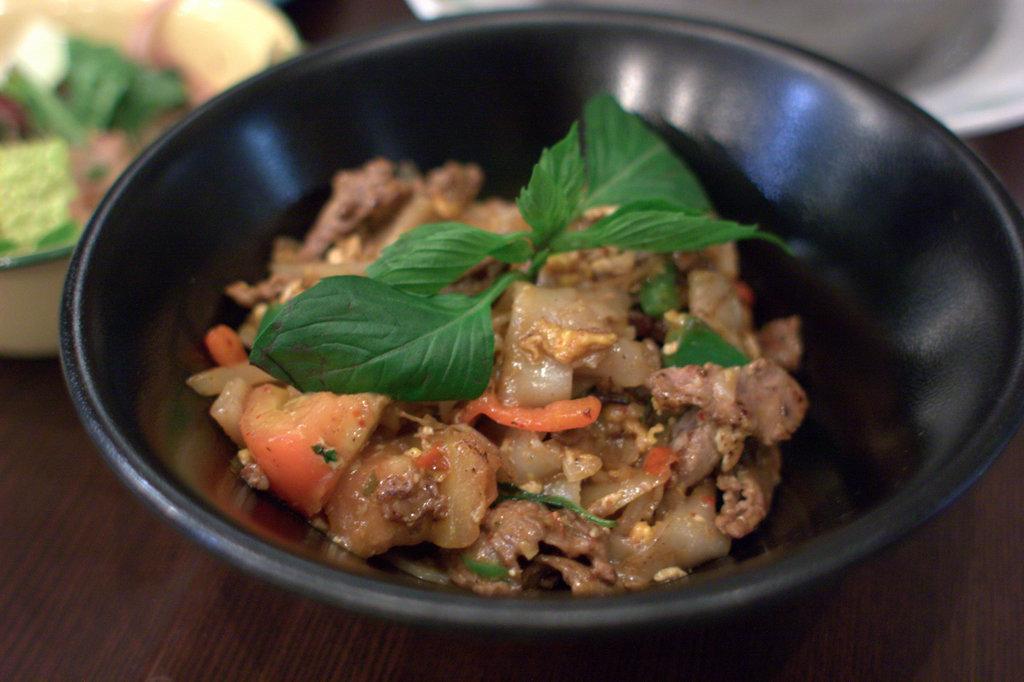Please provide a concise description of this image. In this image we can see some food item which is in black color bowl and in the background of the image there are some other items in bowls. 